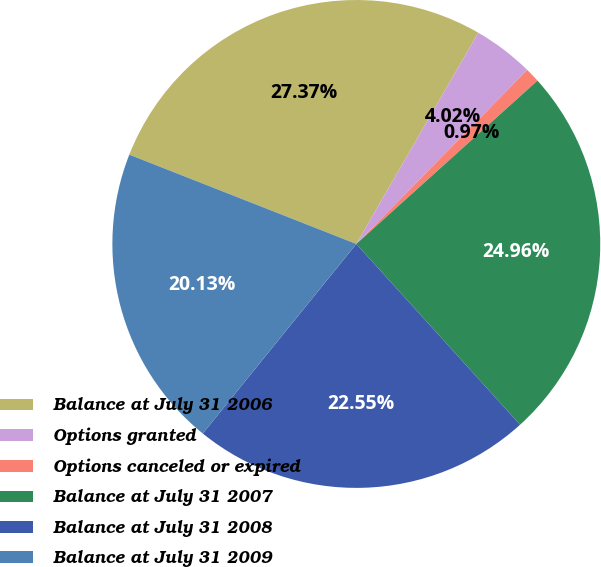Convert chart. <chart><loc_0><loc_0><loc_500><loc_500><pie_chart><fcel>Balance at July 31 2006<fcel>Options granted<fcel>Options canceled or expired<fcel>Balance at July 31 2007<fcel>Balance at July 31 2008<fcel>Balance at July 31 2009<nl><fcel>27.37%<fcel>4.02%<fcel>0.97%<fcel>24.96%<fcel>22.55%<fcel>20.13%<nl></chart> 